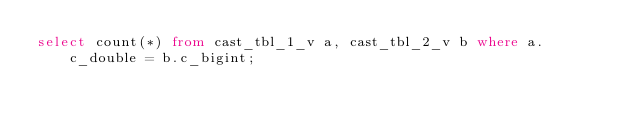<code> <loc_0><loc_0><loc_500><loc_500><_SQL_>select count(*) from cast_tbl_1_v a, cast_tbl_2_v b where a.c_double = b.c_bigint;
</code> 